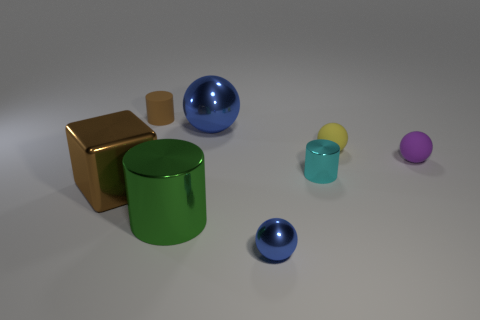Add 1 gray rubber cubes. How many objects exist? 9 Subtract all cylinders. How many objects are left? 5 Add 2 small metal balls. How many small metal balls exist? 3 Subtract 0 blue cylinders. How many objects are left? 8 Subtract all tiny yellow balls. Subtract all small purple balls. How many objects are left? 6 Add 7 tiny purple rubber things. How many tiny purple rubber things are left? 8 